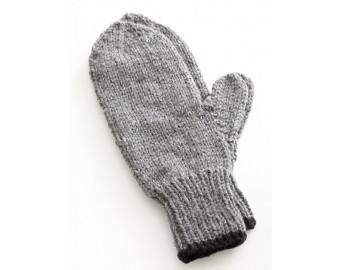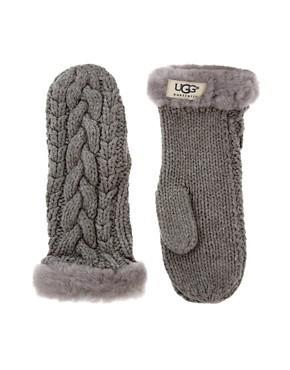The first image is the image on the left, the second image is the image on the right. For the images shown, is this caption "One of the pairs of mittens is gray knit with a vertical braid-like pattern running its length." true? Answer yes or no. Yes. The first image is the image on the left, the second image is the image on the right. Analyze the images presented: Is the assertion "The mittens in the image on the left are made of a solid color." valid? Answer yes or no. Yes. 